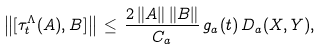<formula> <loc_0><loc_0><loc_500><loc_500>\left \| [ \tau _ { t } ^ { \Lambda } ( A ) , B ] \right \| \, \leq \, \frac { 2 \, \| A \| \, \| B \| } { C _ { a } } \, g _ { a } ( t ) \, D _ { a } ( X , Y ) ,</formula> 